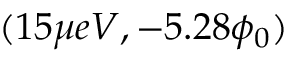<formula> <loc_0><loc_0><loc_500><loc_500>( 1 5 \mu e V , - 5 . 2 8 \phi _ { 0 } )</formula> 